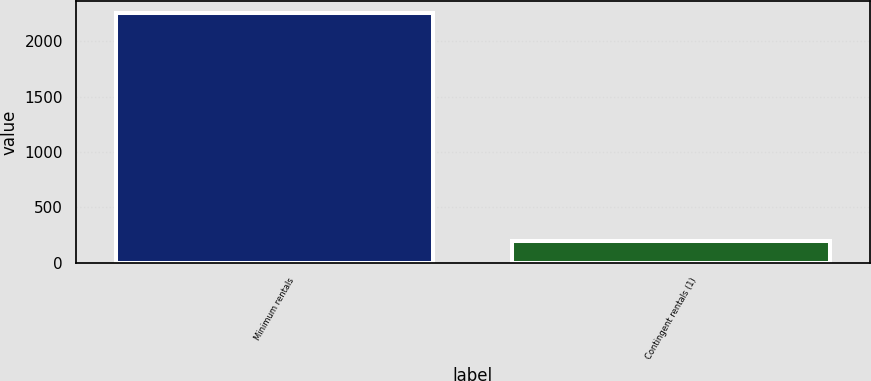<chart> <loc_0><loc_0><loc_500><loc_500><bar_chart><fcel>Minimum rentals<fcel>Contingent rentals (1)<nl><fcel>2249<fcel>194<nl></chart> 